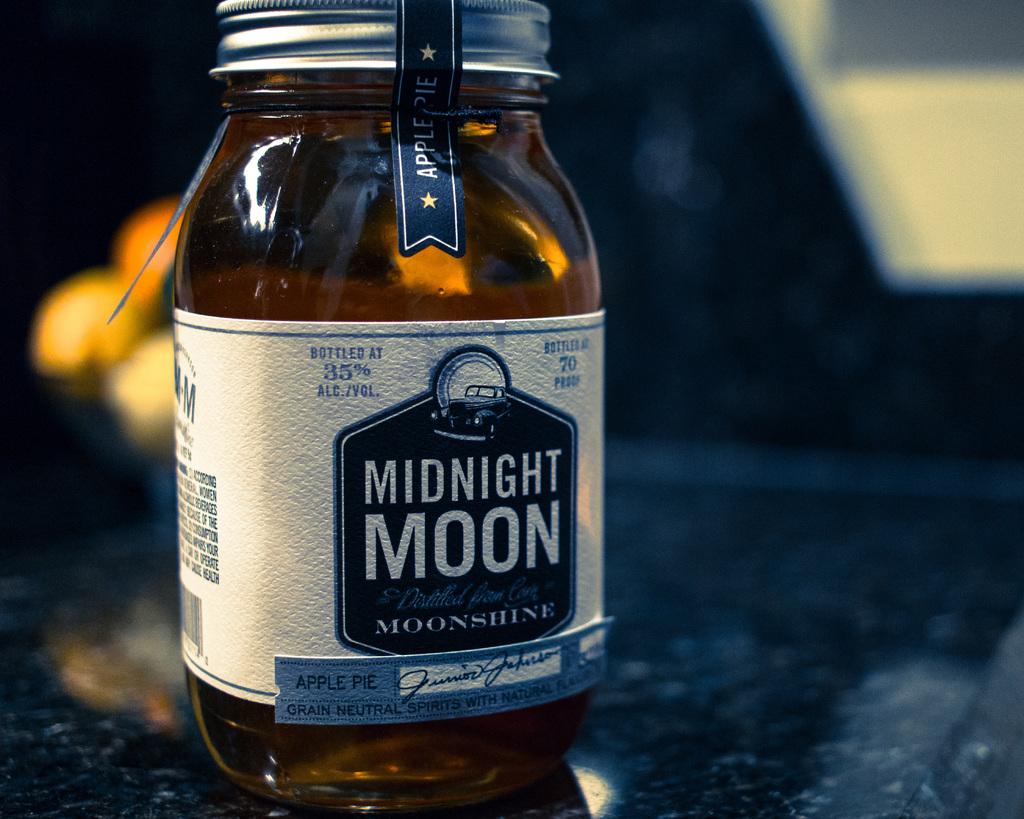What company makes the moonshine?
Keep it short and to the point. Midnight moon. What flavor is this?
Give a very brief answer. Apple pie. 